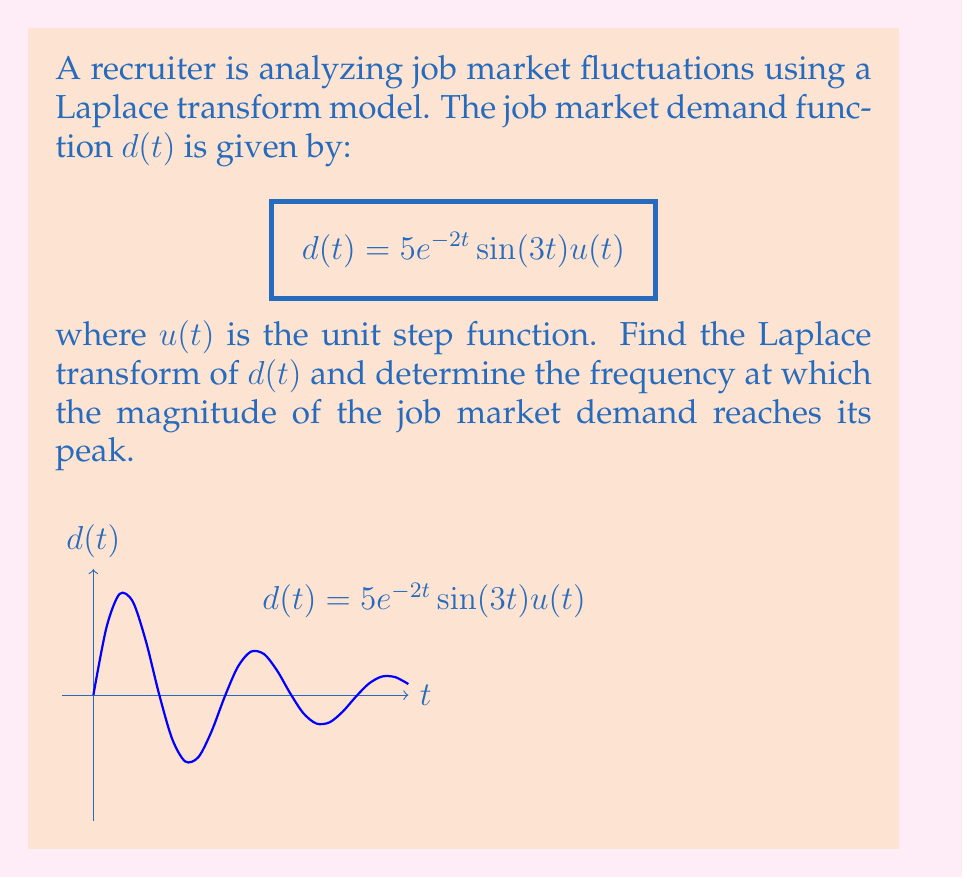Can you answer this question? Let's approach this step-by-step:

1) The Laplace transform of $d(t)$ is denoted as $D(s)$. We need to find:

   $$D(s) = \mathcal{L}\{5e^{-2t}\sin(3t)u(t)\}$$

2) We can use the Laplace transform of a damped sinusoid:

   $$\mathcal{L}\{e^{-at}\sin(bt)u(t)\} = \frac{b}{(s+a)^2 + b^2}$$

3) In our case, $a=2$ and $b=3$. Also, we have a factor of 5. So:

   $$D(s) = \frac{5 \cdot 3}{(s+2)^2 + 3^2} = \frac{15}{s^2 + 4s + 13}$$

4) To find the frequency at which the magnitude peaks, we need to find the transfer function $H(s)$:

   $$H(s) = \frac{D(s)}{U(s)} = \frac{15}{s^2 + 4s + 13}$$

   where $U(s)$ is the Laplace transform of the unit step function.

5) Replace $s$ with $j\omega$ to get the frequency response:

   $$H(j\omega) = \frac{15}{(j\omega)^2 + 4(j\omega) + 13} = \frac{15}{-\omega^2 + 4j\omega + 13}$$

6) The magnitude of $H(j\omega)$ is:

   $$|H(j\omega)| = \frac{15}{\sqrt{(-\omega^2 + 13)^2 + (4\omega)^2}}$$

7) To find the peak, differentiate $|H(j\omega)|$ with respect to $\omega$ and set it to zero. This leads to:

   $$\omega_{peak} = \sqrt{13 - 8} = \sqrt{5} \approx 2.236$$

8) The peak frequency in Hz is:

   $$f_{peak} = \frac{\omega_{peak}}{2\pi} \approx 0.356 \text{ Hz}$$
Answer: $D(s) = \frac{15}{s^2 + 4s + 13}$; Peak frequency $\approx 0.356$ Hz 